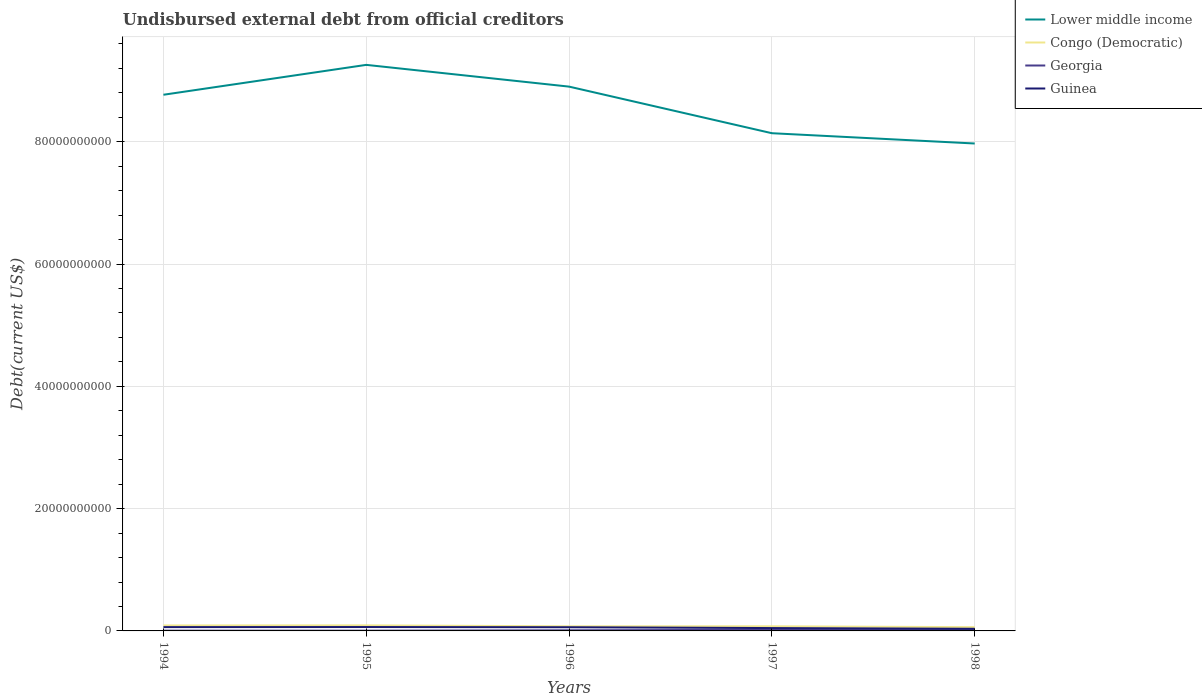How many different coloured lines are there?
Your answer should be very brief. 4. Does the line corresponding to Lower middle income intersect with the line corresponding to Georgia?
Keep it short and to the point. No. Is the number of lines equal to the number of legend labels?
Keep it short and to the point. Yes. Across all years, what is the maximum total debt in Georgia?
Provide a succinct answer. 4.22e+07. What is the total total debt in Georgia in the graph?
Make the answer very short. -6.29e+07. What is the difference between the highest and the second highest total debt in Congo (Democratic)?
Ensure brevity in your answer.  2.93e+08. Is the total debt in Guinea strictly greater than the total debt in Georgia over the years?
Your answer should be compact. No. How many lines are there?
Provide a short and direct response. 4. Does the graph contain any zero values?
Keep it short and to the point. No. Does the graph contain grids?
Give a very brief answer. Yes. Where does the legend appear in the graph?
Make the answer very short. Top right. How many legend labels are there?
Your answer should be compact. 4. How are the legend labels stacked?
Provide a short and direct response. Vertical. What is the title of the graph?
Offer a very short reply. Undisbursed external debt from official creditors. Does "Iraq" appear as one of the legend labels in the graph?
Your answer should be very brief. No. What is the label or title of the Y-axis?
Your response must be concise. Debt(current US$). What is the Debt(current US$) of Lower middle income in 1994?
Your answer should be very brief. 8.77e+1. What is the Debt(current US$) in Congo (Democratic) in 1994?
Provide a succinct answer. 8.93e+08. What is the Debt(current US$) of Georgia in 1994?
Your answer should be compact. 4.58e+07. What is the Debt(current US$) of Guinea in 1994?
Provide a succinct answer. 6.25e+08. What is the Debt(current US$) of Lower middle income in 1995?
Offer a terse response. 9.26e+1. What is the Debt(current US$) in Congo (Democratic) in 1995?
Your answer should be compact. 9.08e+08. What is the Debt(current US$) in Georgia in 1995?
Your answer should be very brief. 4.22e+07. What is the Debt(current US$) of Guinea in 1995?
Provide a short and direct response. 6.36e+08. What is the Debt(current US$) in Lower middle income in 1996?
Provide a short and direct response. 8.90e+1. What is the Debt(current US$) of Congo (Democratic) in 1996?
Offer a terse response. 7.57e+08. What is the Debt(current US$) of Georgia in 1996?
Keep it short and to the point. 1.05e+08. What is the Debt(current US$) in Guinea in 1996?
Give a very brief answer. 6.03e+08. What is the Debt(current US$) in Lower middle income in 1997?
Provide a succinct answer. 8.14e+1. What is the Debt(current US$) of Congo (Democratic) in 1997?
Offer a very short reply. 7.53e+08. What is the Debt(current US$) in Georgia in 1997?
Your answer should be compact. 1.81e+08. What is the Debt(current US$) of Guinea in 1997?
Make the answer very short. 4.68e+08. What is the Debt(current US$) in Lower middle income in 1998?
Your answer should be compact. 7.97e+1. What is the Debt(current US$) in Congo (Democratic) in 1998?
Provide a short and direct response. 6.15e+08. What is the Debt(current US$) in Georgia in 1998?
Offer a terse response. 2.71e+08. What is the Debt(current US$) in Guinea in 1998?
Make the answer very short. 3.50e+08. Across all years, what is the maximum Debt(current US$) in Lower middle income?
Offer a terse response. 9.26e+1. Across all years, what is the maximum Debt(current US$) of Congo (Democratic)?
Your response must be concise. 9.08e+08. Across all years, what is the maximum Debt(current US$) of Georgia?
Offer a terse response. 2.71e+08. Across all years, what is the maximum Debt(current US$) of Guinea?
Make the answer very short. 6.36e+08. Across all years, what is the minimum Debt(current US$) of Lower middle income?
Offer a terse response. 7.97e+1. Across all years, what is the minimum Debt(current US$) in Congo (Democratic)?
Offer a terse response. 6.15e+08. Across all years, what is the minimum Debt(current US$) of Georgia?
Offer a very short reply. 4.22e+07. Across all years, what is the minimum Debt(current US$) in Guinea?
Give a very brief answer. 3.50e+08. What is the total Debt(current US$) of Lower middle income in the graph?
Your response must be concise. 4.30e+11. What is the total Debt(current US$) in Congo (Democratic) in the graph?
Your answer should be very brief. 3.93e+09. What is the total Debt(current US$) of Georgia in the graph?
Make the answer very short. 6.45e+08. What is the total Debt(current US$) of Guinea in the graph?
Provide a short and direct response. 2.68e+09. What is the difference between the Debt(current US$) of Lower middle income in 1994 and that in 1995?
Offer a very short reply. -4.89e+09. What is the difference between the Debt(current US$) of Congo (Democratic) in 1994 and that in 1995?
Keep it short and to the point. -1.47e+07. What is the difference between the Debt(current US$) in Georgia in 1994 and that in 1995?
Give a very brief answer. 3.64e+06. What is the difference between the Debt(current US$) of Guinea in 1994 and that in 1995?
Your response must be concise. -1.12e+07. What is the difference between the Debt(current US$) of Lower middle income in 1994 and that in 1996?
Your response must be concise. -1.33e+09. What is the difference between the Debt(current US$) in Congo (Democratic) in 1994 and that in 1996?
Give a very brief answer. 1.37e+08. What is the difference between the Debt(current US$) of Georgia in 1994 and that in 1996?
Your response must be concise. -5.92e+07. What is the difference between the Debt(current US$) in Guinea in 1994 and that in 1996?
Ensure brevity in your answer.  2.13e+07. What is the difference between the Debt(current US$) of Lower middle income in 1994 and that in 1997?
Your response must be concise. 6.29e+09. What is the difference between the Debt(current US$) in Congo (Democratic) in 1994 and that in 1997?
Your answer should be compact. 1.40e+08. What is the difference between the Debt(current US$) of Georgia in 1994 and that in 1997?
Your answer should be very brief. -1.35e+08. What is the difference between the Debt(current US$) in Guinea in 1994 and that in 1997?
Offer a terse response. 1.56e+08. What is the difference between the Debt(current US$) in Lower middle income in 1994 and that in 1998?
Your response must be concise. 7.97e+09. What is the difference between the Debt(current US$) in Congo (Democratic) in 1994 and that in 1998?
Give a very brief answer. 2.79e+08. What is the difference between the Debt(current US$) in Georgia in 1994 and that in 1998?
Your answer should be very brief. -2.25e+08. What is the difference between the Debt(current US$) of Guinea in 1994 and that in 1998?
Your response must be concise. 2.75e+08. What is the difference between the Debt(current US$) of Lower middle income in 1995 and that in 1996?
Your answer should be compact. 3.56e+09. What is the difference between the Debt(current US$) in Congo (Democratic) in 1995 and that in 1996?
Your answer should be very brief. 1.51e+08. What is the difference between the Debt(current US$) in Georgia in 1995 and that in 1996?
Your answer should be very brief. -6.29e+07. What is the difference between the Debt(current US$) in Guinea in 1995 and that in 1996?
Your answer should be compact. 3.25e+07. What is the difference between the Debt(current US$) in Lower middle income in 1995 and that in 1997?
Offer a terse response. 1.12e+1. What is the difference between the Debt(current US$) of Congo (Democratic) in 1995 and that in 1997?
Your response must be concise. 1.55e+08. What is the difference between the Debt(current US$) in Georgia in 1995 and that in 1997?
Offer a terse response. -1.39e+08. What is the difference between the Debt(current US$) of Guinea in 1995 and that in 1997?
Offer a terse response. 1.67e+08. What is the difference between the Debt(current US$) in Lower middle income in 1995 and that in 1998?
Your answer should be very brief. 1.29e+1. What is the difference between the Debt(current US$) in Congo (Democratic) in 1995 and that in 1998?
Provide a short and direct response. 2.93e+08. What is the difference between the Debt(current US$) of Georgia in 1995 and that in 1998?
Make the answer very short. -2.29e+08. What is the difference between the Debt(current US$) of Guinea in 1995 and that in 1998?
Your answer should be compact. 2.86e+08. What is the difference between the Debt(current US$) of Lower middle income in 1996 and that in 1997?
Your response must be concise. 7.62e+09. What is the difference between the Debt(current US$) of Congo (Democratic) in 1996 and that in 1997?
Ensure brevity in your answer.  3.16e+06. What is the difference between the Debt(current US$) of Georgia in 1996 and that in 1997?
Your response must be concise. -7.58e+07. What is the difference between the Debt(current US$) in Guinea in 1996 and that in 1997?
Give a very brief answer. 1.35e+08. What is the difference between the Debt(current US$) of Lower middle income in 1996 and that in 1998?
Make the answer very short. 9.30e+09. What is the difference between the Debt(current US$) of Congo (Democratic) in 1996 and that in 1998?
Provide a short and direct response. 1.42e+08. What is the difference between the Debt(current US$) in Georgia in 1996 and that in 1998?
Provide a succinct answer. -1.66e+08. What is the difference between the Debt(current US$) in Guinea in 1996 and that in 1998?
Ensure brevity in your answer.  2.53e+08. What is the difference between the Debt(current US$) of Lower middle income in 1997 and that in 1998?
Offer a terse response. 1.68e+09. What is the difference between the Debt(current US$) of Congo (Democratic) in 1997 and that in 1998?
Make the answer very short. 1.39e+08. What is the difference between the Debt(current US$) in Georgia in 1997 and that in 1998?
Provide a short and direct response. -8.99e+07. What is the difference between the Debt(current US$) of Guinea in 1997 and that in 1998?
Your answer should be compact. 1.18e+08. What is the difference between the Debt(current US$) of Lower middle income in 1994 and the Debt(current US$) of Congo (Democratic) in 1995?
Give a very brief answer. 8.68e+1. What is the difference between the Debt(current US$) in Lower middle income in 1994 and the Debt(current US$) in Georgia in 1995?
Provide a succinct answer. 8.76e+1. What is the difference between the Debt(current US$) of Lower middle income in 1994 and the Debt(current US$) of Guinea in 1995?
Keep it short and to the point. 8.71e+1. What is the difference between the Debt(current US$) in Congo (Democratic) in 1994 and the Debt(current US$) in Georgia in 1995?
Keep it short and to the point. 8.51e+08. What is the difference between the Debt(current US$) in Congo (Democratic) in 1994 and the Debt(current US$) in Guinea in 1995?
Offer a terse response. 2.57e+08. What is the difference between the Debt(current US$) in Georgia in 1994 and the Debt(current US$) in Guinea in 1995?
Give a very brief answer. -5.90e+08. What is the difference between the Debt(current US$) of Lower middle income in 1994 and the Debt(current US$) of Congo (Democratic) in 1996?
Keep it short and to the point. 8.69e+1. What is the difference between the Debt(current US$) of Lower middle income in 1994 and the Debt(current US$) of Georgia in 1996?
Provide a short and direct response. 8.76e+1. What is the difference between the Debt(current US$) in Lower middle income in 1994 and the Debt(current US$) in Guinea in 1996?
Provide a short and direct response. 8.71e+1. What is the difference between the Debt(current US$) in Congo (Democratic) in 1994 and the Debt(current US$) in Georgia in 1996?
Give a very brief answer. 7.88e+08. What is the difference between the Debt(current US$) in Congo (Democratic) in 1994 and the Debt(current US$) in Guinea in 1996?
Your answer should be compact. 2.90e+08. What is the difference between the Debt(current US$) of Georgia in 1994 and the Debt(current US$) of Guinea in 1996?
Your answer should be compact. -5.58e+08. What is the difference between the Debt(current US$) of Lower middle income in 1994 and the Debt(current US$) of Congo (Democratic) in 1997?
Offer a very short reply. 8.69e+1. What is the difference between the Debt(current US$) in Lower middle income in 1994 and the Debt(current US$) in Georgia in 1997?
Keep it short and to the point. 8.75e+1. What is the difference between the Debt(current US$) in Lower middle income in 1994 and the Debt(current US$) in Guinea in 1997?
Ensure brevity in your answer.  8.72e+1. What is the difference between the Debt(current US$) in Congo (Democratic) in 1994 and the Debt(current US$) in Georgia in 1997?
Your response must be concise. 7.13e+08. What is the difference between the Debt(current US$) in Congo (Democratic) in 1994 and the Debt(current US$) in Guinea in 1997?
Your response must be concise. 4.25e+08. What is the difference between the Debt(current US$) of Georgia in 1994 and the Debt(current US$) of Guinea in 1997?
Your response must be concise. -4.23e+08. What is the difference between the Debt(current US$) in Lower middle income in 1994 and the Debt(current US$) in Congo (Democratic) in 1998?
Your answer should be compact. 8.71e+1. What is the difference between the Debt(current US$) of Lower middle income in 1994 and the Debt(current US$) of Georgia in 1998?
Your response must be concise. 8.74e+1. What is the difference between the Debt(current US$) of Lower middle income in 1994 and the Debt(current US$) of Guinea in 1998?
Offer a terse response. 8.73e+1. What is the difference between the Debt(current US$) of Congo (Democratic) in 1994 and the Debt(current US$) of Georgia in 1998?
Keep it short and to the point. 6.23e+08. What is the difference between the Debt(current US$) of Congo (Democratic) in 1994 and the Debt(current US$) of Guinea in 1998?
Offer a very short reply. 5.43e+08. What is the difference between the Debt(current US$) in Georgia in 1994 and the Debt(current US$) in Guinea in 1998?
Give a very brief answer. -3.04e+08. What is the difference between the Debt(current US$) in Lower middle income in 1995 and the Debt(current US$) in Congo (Democratic) in 1996?
Your response must be concise. 9.18e+1. What is the difference between the Debt(current US$) of Lower middle income in 1995 and the Debt(current US$) of Georgia in 1996?
Give a very brief answer. 9.25e+1. What is the difference between the Debt(current US$) of Lower middle income in 1995 and the Debt(current US$) of Guinea in 1996?
Your answer should be compact. 9.20e+1. What is the difference between the Debt(current US$) in Congo (Democratic) in 1995 and the Debt(current US$) in Georgia in 1996?
Keep it short and to the point. 8.03e+08. What is the difference between the Debt(current US$) of Congo (Democratic) in 1995 and the Debt(current US$) of Guinea in 1996?
Ensure brevity in your answer.  3.05e+08. What is the difference between the Debt(current US$) of Georgia in 1995 and the Debt(current US$) of Guinea in 1996?
Give a very brief answer. -5.61e+08. What is the difference between the Debt(current US$) of Lower middle income in 1995 and the Debt(current US$) of Congo (Democratic) in 1997?
Give a very brief answer. 9.18e+1. What is the difference between the Debt(current US$) of Lower middle income in 1995 and the Debt(current US$) of Georgia in 1997?
Your response must be concise. 9.24e+1. What is the difference between the Debt(current US$) of Lower middle income in 1995 and the Debt(current US$) of Guinea in 1997?
Your answer should be very brief. 9.21e+1. What is the difference between the Debt(current US$) in Congo (Democratic) in 1995 and the Debt(current US$) in Georgia in 1997?
Keep it short and to the point. 7.27e+08. What is the difference between the Debt(current US$) in Congo (Democratic) in 1995 and the Debt(current US$) in Guinea in 1997?
Keep it short and to the point. 4.40e+08. What is the difference between the Debt(current US$) in Georgia in 1995 and the Debt(current US$) in Guinea in 1997?
Provide a short and direct response. -4.26e+08. What is the difference between the Debt(current US$) of Lower middle income in 1995 and the Debt(current US$) of Congo (Democratic) in 1998?
Your answer should be very brief. 9.20e+1. What is the difference between the Debt(current US$) of Lower middle income in 1995 and the Debt(current US$) of Georgia in 1998?
Give a very brief answer. 9.23e+1. What is the difference between the Debt(current US$) in Lower middle income in 1995 and the Debt(current US$) in Guinea in 1998?
Keep it short and to the point. 9.22e+1. What is the difference between the Debt(current US$) in Congo (Democratic) in 1995 and the Debt(current US$) in Georgia in 1998?
Offer a very short reply. 6.37e+08. What is the difference between the Debt(current US$) in Congo (Democratic) in 1995 and the Debt(current US$) in Guinea in 1998?
Provide a succinct answer. 5.58e+08. What is the difference between the Debt(current US$) in Georgia in 1995 and the Debt(current US$) in Guinea in 1998?
Your response must be concise. -3.08e+08. What is the difference between the Debt(current US$) in Lower middle income in 1996 and the Debt(current US$) in Congo (Democratic) in 1997?
Make the answer very short. 8.83e+1. What is the difference between the Debt(current US$) of Lower middle income in 1996 and the Debt(current US$) of Georgia in 1997?
Provide a short and direct response. 8.88e+1. What is the difference between the Debt(current US$) in Lower middle income in 1996 and the Debt(current US$) in Guinea in 1997?
Ensure brevity in your answer.  8.86e+1. What is the difference between the Debt(current US$) in Congo (Democratic) in 1996 and the Debt(current US$) in Georgia in 1997?
Provide a succinct answer. 5.76e+08. What is the difference between the Debt(current US$) in Congo (Democratic) in 1996 and the Debt(current US$) in Guinea in 1997?
Your response must be concise. 2.88e+08. What is the difference between the Debt(current US$) of Georgia in 1996 and the Debt(current US$) of Guinea in 1997?
Make the answer very short. -3.63e+08. What is the difference between the Debt(current US$) of Lower middle income in 1996 and the Debt(current US$) of Congo (Democratic) in 1998?
Your answer should be very brief. 8.84e+1. What is the difference between the Debt(current US$) of Lower middle income in 1996 and the Debt(current US$) of Georgia in 1998?
Your response must be concise. 8.87e+1. What is the difference between the Debt(current US$) of Lower middle income in 1996 and the Debt(current US$) of Guinea in 1998?
Keep it short and to the point. 8.87e+1. What is the difference between the Debt(current US$) of Congo (Democratic) in 1996 and the Debt(current US$) of Georgia in 1998?
Ensure brevity in your answer.  4.86e+08. What is the difference between the Debt(current US$) in Congo (Democratic) in 1996 and the Debt(current US$) in Guinea in 1998?
Offer a very short reply. 4.06e+08. What is the difference between the Debt(current US$) in Georgia in 1996 and the Debt(current US$) in Guinea in 1998?
Give a very brief answer. -2.45e+08. What is the difference between the Debt(current US$) in Lower middle income in 1997 and the Debt(current US$) in Congo (Democratic) in 1998?
Give a very brief answer. 8.08e+1. What is the difference between the Debt(current US$) of Lower middle income in 1997 and the Debt(current US$) of Georgia in 1998?
Your response must be concise. 8.11e+1. What is the difference between the Debt(current US$) in Lower middle income in 1997 and the Debt(current US$) in Guinea in 1998?
Ensure brevity in your answer.  8.10e+1. What is the difference between the Debt(current US$) in Congo (Democratic) in 1997 and the Debt(current US$) in Georgia in 1998?
Make the answer very short. 4.83e+08. What is the difference between the Debt(current US$) in Congo (Democratic) in 1997 and the Debt(current US$) in Guinea in 1998?
Give a very brief answer. 4.03e+08. What is the difference between the Debt(current US$) in Georgia in 1997 and the Debt(current US$) in Guinea in 1998?
Offer a very short reply. -1.69e+08. What is the average Debt(current US$) in Lower middle income per year?
Give a very brief answer. 8.61e+1. What is the average Debt(current US$) in Congo (Democratic) per year?
Offer a very short reply. 7.85e+08. What is the average Debt(current US$) in Georgia per year?
Give a very brief answer. 1.29e+08. What is the average Debt(current US$) in Guinea per year?
Ensure brevity in your answer.  5.37e+08. In the year 1994, what is the difference between the Debt(current US$) of Lower middle income and Debt(current US$) of Congo (Democratic)?
Offer a very short reply. 8.68e+1. In the year 1994, what is the difference between the Debt(current US$) in Lower middle income and Debt(current US$) in Georgia?
Offer a very short reply. 8.76e+1. In the year 1994, what is the difference between the Debt(current US$) in Lower middle income and Debt(current US$) in Guinea?
Keep it short and to the point. 8.71e+1. In the year 1994, what is the difference between the Debt(current US$) of Congo (Democratic) and Debt(current US$) of Georgia?
Your answer should be compact. 8.48e+08. In the year 1994, what is the difference between the Debt(current US$) in Congo (Democratic) and Debt(current US$) in Guinea?
Provide a short and direct response. 2.69e+08. In the year 1994, what is the difference between the Debt(current US$) in Georgia and Debt(current US$) in Guinea?
Make the answer very short. -5.79e+08. In the year 1995, what is the difference between the Debt(current US$) of Lower middle income and Debt(current US$) of Congo (Democratic)?
Offer a very short reply. 9.17e+1. In the year 1995, what is the difference between the Debt(current US$) of Lower middle income and Debt(current US$) of Georgia?
Keep it short and to the point. 9.25e+1. In the year 1995, what is the difference between the Debt(current US$) in Lower middle income and Debt(current US$) in Guinea?
Your response must be concise. 9.19e+1. In the year 1995, what is the difference between the Debt(current US$) in Congo (Democratic) and Debt(current US$) in Georgia?
Your answer should be very brief. 8.66e+08. In the year 1995, what is the difference between the Debt(current US$) in Congo (Democratic) and Debt(current US$) in Guinea?
Keep it short and to the point. 2.72e+08. In the year 1995, what is the difference between the Debt(current US$) in Georgia and Debt(current US$) in Guinea?
Keep it short and to the point. -5.94e+08. In the year 1996, what is the difference between the Debt(current US$) in Lower middle income and Debt(current US$) in Congo (Democratic)?
Offer a terse response. 8.83e+1. In the year 1996, what is the difference between the Debt(current US$) of Lower middle income and Debt(current US$) of Georgia?
Give a very brief answer. 8.89e+1. In the year 1996, what is the difference between the Debt(current US$) of Lower middle income and Debt(current US$) of Guinea?
Keep it short and to the point. 8.84e+1. In the year 1996, what is the difference between the Debt(current US$) in Congo (Democratic) and Debt(current US$) in Georgia?
Keep it short and to the point. 6.52e+08. In the year 1996, what is the difference between the Debt(current US$) of Congo (Democratic) and Debt(current US$) of Guinea?
Provide a succinct answer. 1.53e+08. In the year 1996, what is the difference between the Debt(current US$) of Georgia and Debt(current US$) of Guinea?
Ensure brevity in your answer.  -4.98e+08. In the year 1997, what is the difference between the Debt(current US$) of Lower middle income and Debt(current US$) of Congo (Democratic)?
Offer a terse response. 8.06e+1. In the year 1997, what is the difference between the Debt(current US$) in Lower middle income and Debt(current US$) in Georgia?
Your answer should be very brief. 8.12e+1. In the year 1997, what is the difference between the Debt(current US$) in Lower middle income and Debt(current US$) in Guinea?
Keep it short and to the point. 8.09e+1. In the year 1997, what is the difference between the Debt(current US$) of Congo (Democratic) and Debt(current US$) of Georgia?
Keep it short and to the point. 5.73e+08. In the year 1997, what is the difference between the Debt(current US$) of Congo (Democratic) and Debt(current US$) of Guinea?
Give a very brief answer. 2.85e+08. In the year 1997, what is the difference between the Debt(current US$) in Georgia and Debt(current US$) in Guinea?
Provide a short and direct response. -2.88e+08. In the year 1998, what is the difference between the Debt(current US$) in Lower middle income and Debt(current US$) in Congo (Democratic)?
Your answer should be very brief. 7.91e+1. In the year 1998, what is the difference between the Debt(current US$) of Lower middle income and Debt(current US$) of Georgia?
Offer a terse response. 7.94e+1. In the year 1998, what is the difference between the Debt(current US$) in Lower middle income and Debt(current US$) in Guinea?
Keep it short and to the point. 7.94e+1. In the year 1998, what is the difference between the Debt(current US$) in Congo (Democratic) and Debt(current US$) in Georgia?
Offer a terse response. 3.44e+08. In the year 1998, what is the difference between the Debt(current US$) of Congo (Democratic) and Debt(current US$) of Guinea?
Give a very brief answer. 2.64e+08. In the year 1998, what is the difference between the Debt(current US$) in Georgia and Debt(current US$) in Guinea?
Make the answer very short. -7.94e+07. What is the ratio of the Debt(current US$) in Lower middle income in 1994 to that in 1995?
Provide a succinct answer. 0.95. What is the ratio of the Debt(current US$) of Congo (Democratic) in 1994 to that in 1995?
Offer a very short reply. 0.98. What is the ratio of the Debt(current US$) of Georgia in 1994 to that in 1995?
Your answer should be compact. 1.09. What is the ratio of the Debt(current US$) in Guinea in 1994 to that in 1995?
Keep it short and to the point. 0.98. What is the ratio of the Debt(current US$) of Lower middle income in 1994 to that in 1996?
Your response must be concise. 0.99. What is the ratio of the Debt(current US$) in Congo (Democratic) in 1994 to that in 1996?
Ensure brevity in your answer.  1.18. What is the ratio of the Debt(current US$) in Georgia in 1994 to that in 1996?
Offer a very short reply. 0.44. What is the ratio of the Debt(current US$) of Guinea in 1994 to that in 1996?
Your response must be concise. 1.04. What is the ratio of the Debt(current US$) in Lower middle income in 1994 to that in 1997?
Your response must be concise. 1.08. What is the ratio of the Debt(current US$) of Congo (Democratic) in 1994 to that in 1997?
Your response must be concise. 1.19. What is the ratio of the Debt(current US$) in Georgia in 1994 to that in 1997?
Your response must be concise. 0.25. What is the ratio of the Debt(current US$) in Guinea in 1994 to that in 1997?
Give a very brief answer. 1.33. What is the ratio of the Debt(current US$) in Congo (Democratic) in 1994 to that in 1998?
Your answer should be compact. 1.45. What is the ratio of the Debt(current US$) in Georgia in 1994 to that in 1998?
Your answer should be compact. 0.17. What is the ratio of the Debt(current US$) of Guinea in 1994 to that in 1998?
Ensure brevity in your answer.  1.78. What is the ratio of the Debt(current US$) of Congo (Democratic) in 1995 to that in 1996?
Keep it short and to the point. 1.2. What is the ratio of the Debt(current US$) in Georgia in 1995 to that in 1996?
Offer a very short reply. 0.4. What is the ratio of the Debt(current US$) of Guinea in 1995 to that in 1996?
Offer a very short reply. 1.05. What is the ratio of the Debt(current US$) of Lower middle income in 1995 to that in 1997?
Provide a succinct answer. 1.14. What is the ratio of the Debt(current US$) in Congo (Democratic) in 1995 to that in 1997?
Provide a succinct answer. 1.21. What is the ratio of the Debt(current US$) of Georgia in 1995 to that in 1997?
Your response must be concise. 0.23. What is the ratio of the Debt(current US$) in Guinea in 1995 to that in 1997?
Your answer should be compact. 1.36. What is the ratio of the Debt(current US$) of Lower middle income in 1995 to that in 1998?
Offer a terse response. 1.16. What is the ratio of the Debt(current US$) of Congo (Democratic) in 1995 to that in 1998?
Your answer should be very brief. 1.48. What is the ratio of the Debt(current US$) of Georgia in 1995 to that in 1998?
Give a very brief answer. 0.16. What is the ratio of the Debt(current US$) in Guinea in 1995 to that in 1998?
Make the answer very short. 1.82. What is the ratio of the Debt(current US$) in Lower middle income in 1996 to that in 1997?
Your answer should be very brief. 1.09. What is the ratio of the Debt(current US$) in Georgia in 1996 to that in 1997?
Ensure brevity in your answer.  0.58. What is the ratio of the Debt(current US$) of Guinea in 1996 to that in 1997?
Your response must be concise. 1.29. What is the ratio of the Debt(current US$) in Lower middle income in 1996 to that in 1998?
Provide a short and direct response. 1.12. What is the ratio of the Debt(current US$) of Congo (Democratic) in 1996 to that in 1998?
Your response must be concise. 1.23. What is the ratio of the Debt(current US$) in Georgia in 1996 to that in 1998?
Provide a succinct answer. 0.39. What is the ratio of the Debt(current US$) in Guinea in 1996 to that in 1998?
Make the answer very short. 1.72. What is the ratio of the Debt(current US$) in Lower middle income in 1997 to that in 1998?
Make the answer very short. 1.02. What is the ratio of the Debt(current US$) in Congo (Democratic) in 1997 to that in 1998?
Offer a terse response. 1.23. What is the ratio of the Debt(current US$) in Georgia in 1997 to that in 1998?
Give a very brief answer. 0.67. What is the ratio of the Debt(current US$) of Guinea in 1997 to that in 1998?
Offer a terse response. 1.34. What is the difference between the highest and the second highest Debt(current US$) of Lower middle income?
Make the answer very short. 3.56e+09. What is the difference between the highest and the second highest Debt(current US$) in Congo (Democratic)?
Provide a short and direct response. 1.47e+07. What is the difference between the highest and the second highest Debt(current US$) in Georgia?
Your answer should be very brief. 8.99e+07. What is the difference between the highest and the second highest Debt(current US$) in Guinea?
Your answer should be very brief. 1.12e+07. What is the difference between the highest and the lowest Debt(current US$) in Lower middle income?
Your answer should be very brief. 1.29e+1. What is the difference between the highest and the lowest Debt(current US$) in Congo (Democratic)?
Give a very brief answer. 2.93e+08. What is the difference between the highest and the lowest Debt(current US$) in Georgia?
Provide a short and direct response. 2.29e+08. What is the difference between the highest and the lowest Debt(current US$) of Guinea?
Provide a succinct answer. 2.86e+08. 